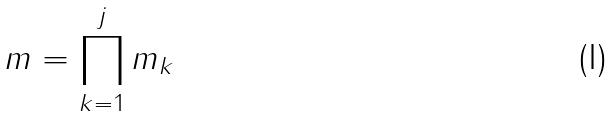<formula> <loc_0><loc_0><loc_500><loc_500>m = \prod _ { k = 1 } ^ { j } m _ { k }</formula> 